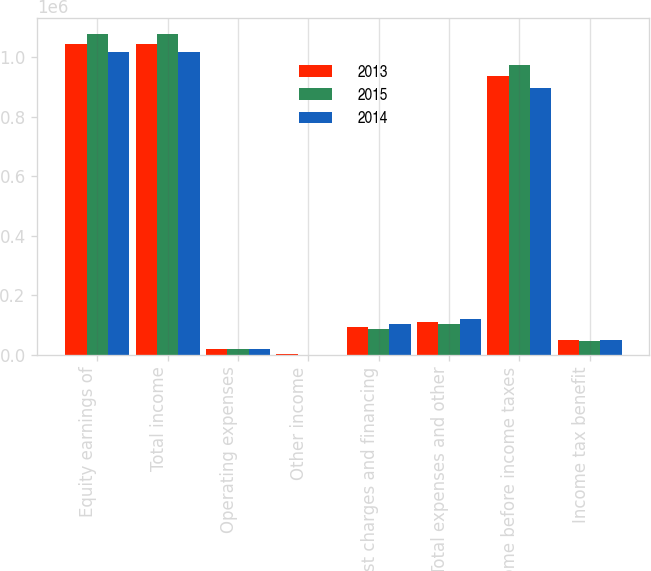Convert chart to OTSL. <chart><loc_0><loc_0><loc_500><loc_500><stacked_bar_chart><ecel><fcel>Equity earnings of<fcel>Total income<fcel>Operating expenses<fcel>Other income<fcel>Interest charges and financing<fcel>Total expenses and other<fcel>Income before income taxes<fcel>Income tax benefit<nl><fcel>2013<fcel>1.04579e+06<fcel>1.04579e+06<fcel>19865<fcel>1242<fcel>91801<fcel>110424<fcel>935364<fcel>49121<nl><fcel>2015<fcel>1.07771e+06<fcel>1.07771e+06<fcel>19756<fcel>537<fcel>84830<fcel>104049<fcel>973665<fcel>47641<nl><fcel>2014<fcel>1.01878e+06<fcel>1.01878e+06<fcel>18513<fcel>206<fcel>102914<fcel>121221<fcel>897562<fcel>50672<nl></chart> 